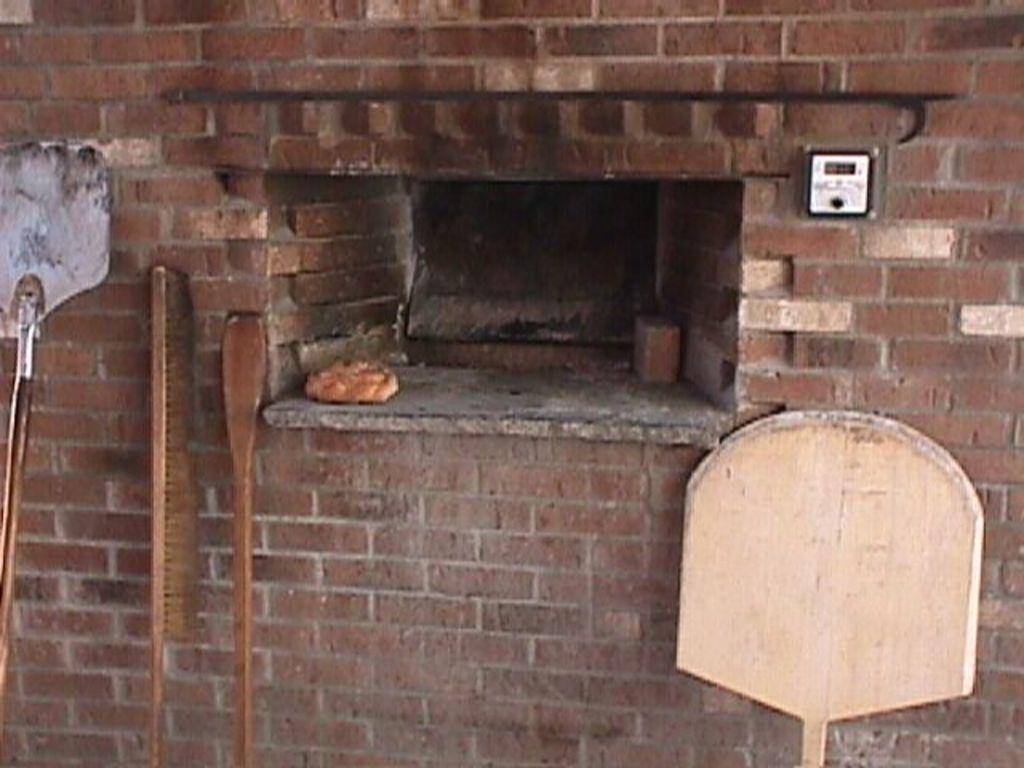Please provide a concise description of this image. In this image, we can see sticks and in the background, there is a meter placed on the wall. 